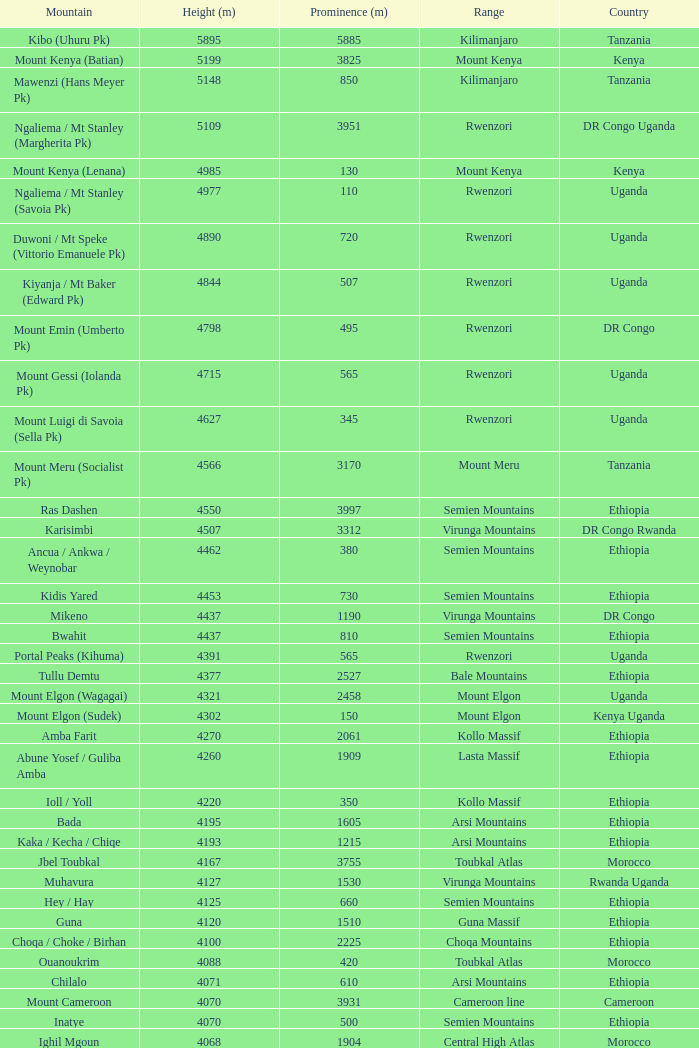How tall is the Mountain of jbel ghat? 1.0. 